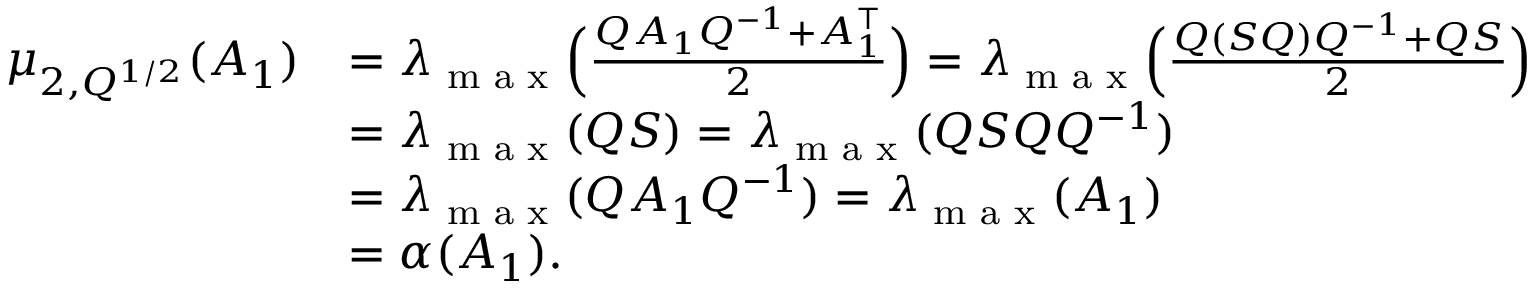<formula> <loc_0><loc_0><loc_500><loc_500>\begin{array} { r l } { \mu _ { 2 , Q ^ { 1 / 2 } } ( A _ { 1 } ) } & { = \lambda _ { \max } \left ( \frac { Q A _ { 1 } Q ^ { - 1 } { + } A _ { 1 } ^ { \top } } { 2 } \right ) = \lambda _ { \max } \left ( \frac { Q ( S Q ) Q ^ { - 1 } { + } Q S } { 2 } \right ) } \\ & { = \lambda _ { \max } ( Q S ) = \lambda _ { \max } ( Q S Q Q ^ { - 1 } ) } \\ & { = \lambda _ { \max } ( Q A _ { 1 } Q ^ { - 1 } ) = \lambda _ { \max } ( A _ { 1 } ) } \\ & { = \alpha ( A _ { 1 } ) . } \end{array}</formula> 